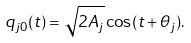<formula> <loc_0><loc_0><loc_500><loc_500>q _ { j 0 } ( t ) = \sqrt { 2 A _ { j } } \cos ( t + \theta _ { j } ) .</formula> 